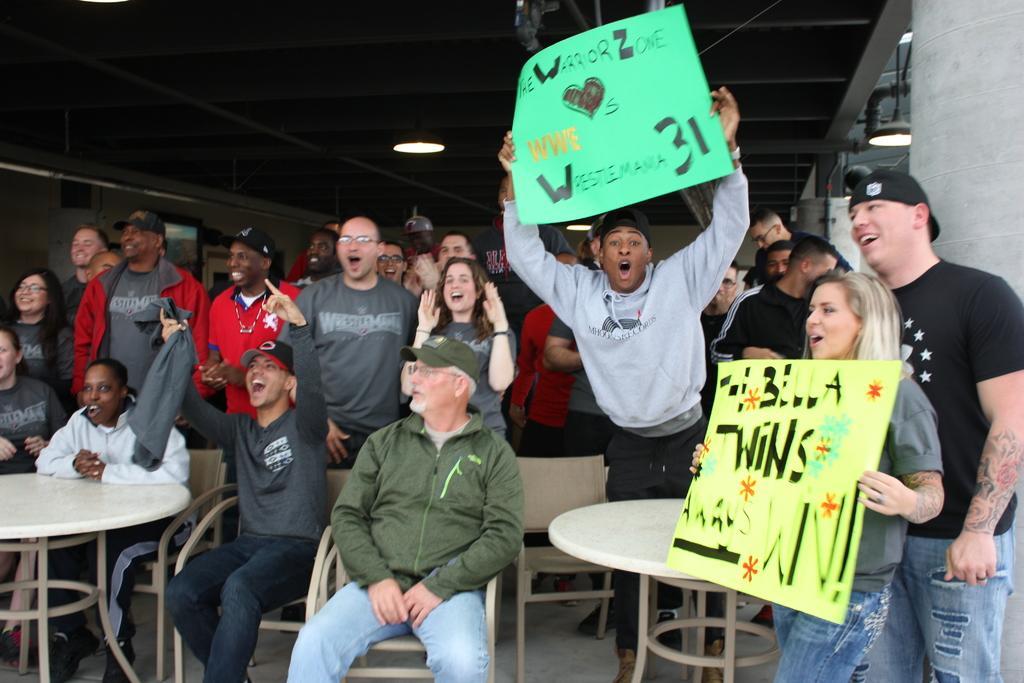Describe this image in one or two sentences. In this image there are many people. In the middle is a man he is sitting on the chair, he wears jacket, cap and trouser. On the right there is table, some people,wall and light. In the middle there is a man he holds a poster. On the left there is table and some people. 